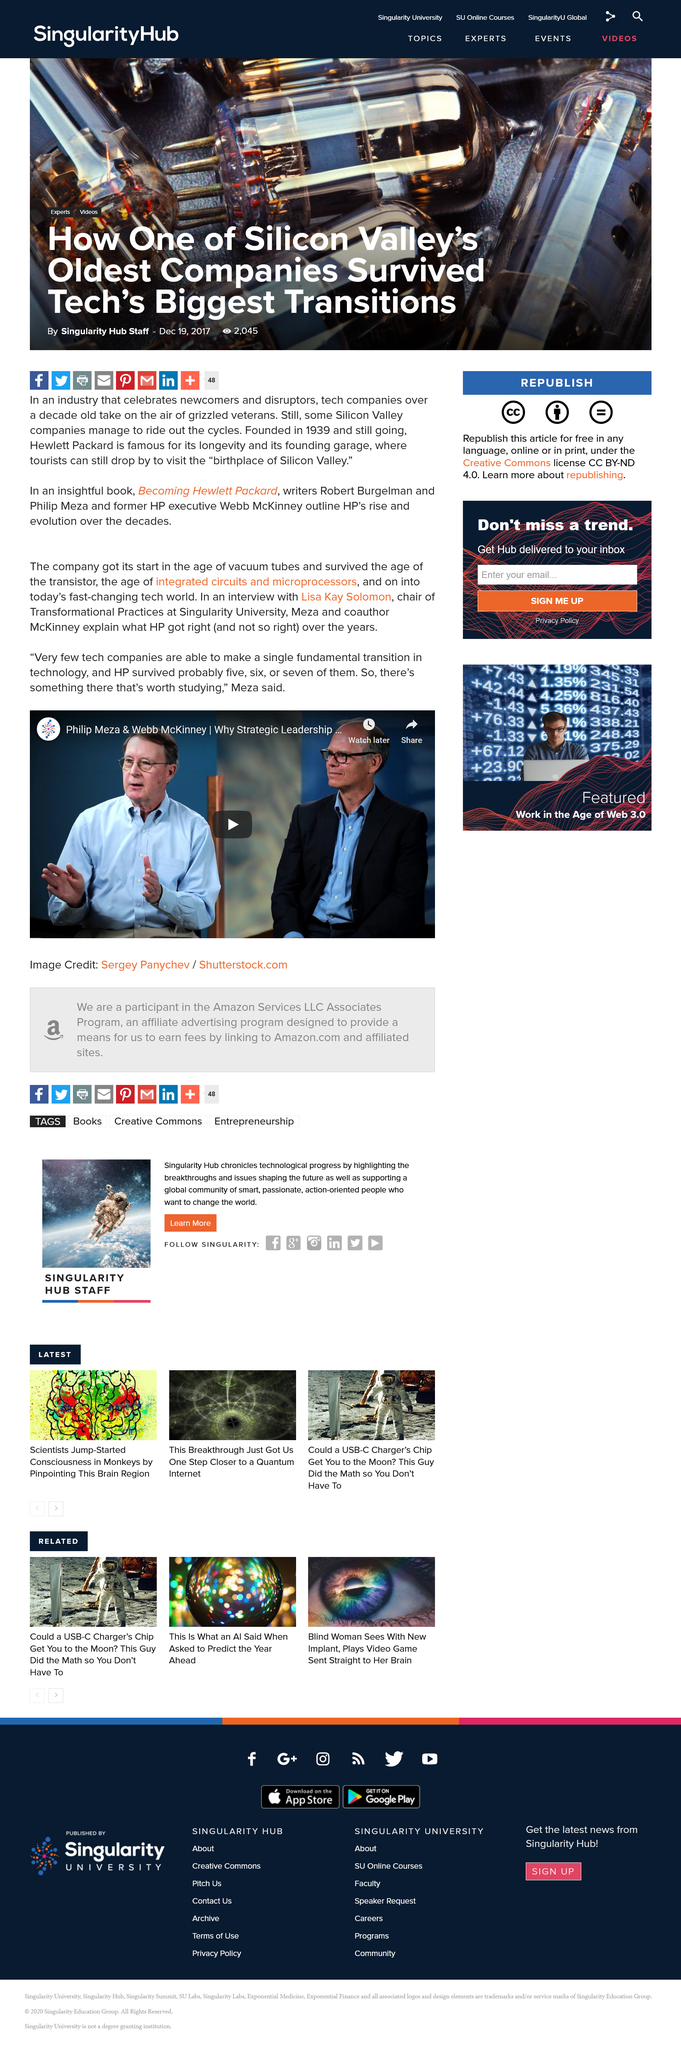List a handful of essential elements in this visual. The first name of the interviewee is Lisa. The person holding the position of Chair of Transformational Practices at Singularity University is named Philip Meza. The article mentions that the company that survived "probably five, six, or seven fundamental transitions" is HP. 